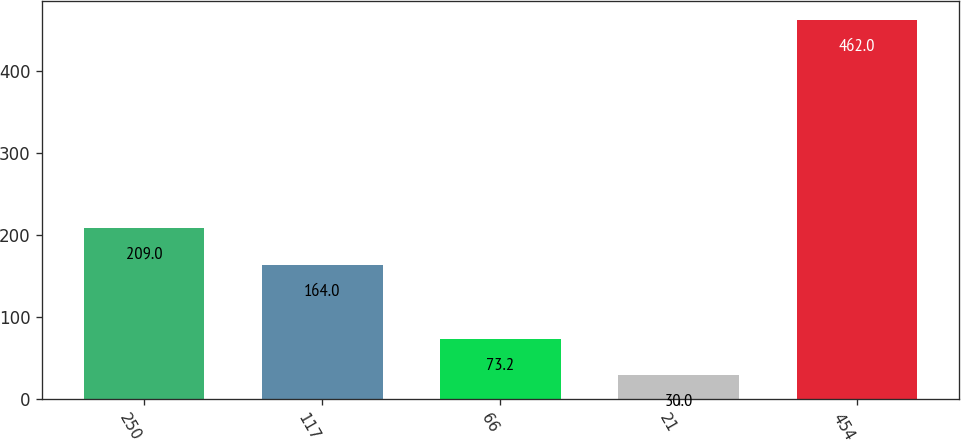Convert chart to OTSL. <chart><loc_0><loc_0><loc_500><loc_500><bar_chart><fcel>250<fcel>117<fcel>66<fcel>21<fcel>454<nl><fcel>209<fcel>164<fcel>73.2<fcel>30<fcel>462<nl></chart> 